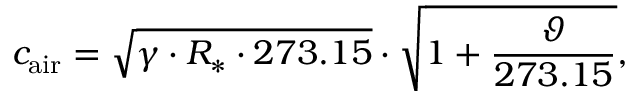<formula> <loc_0><loc_0><loc_500><loc_500>c _ { a i r } = { \sqrt { \gamma \cdot R _ { * } \cdot 2 7 3 . 1 5 } } \cdot { \sqrt { 1 + { \frac { \vartheta } { 2 7 3 . 1 5 } } } } ,</formula> 